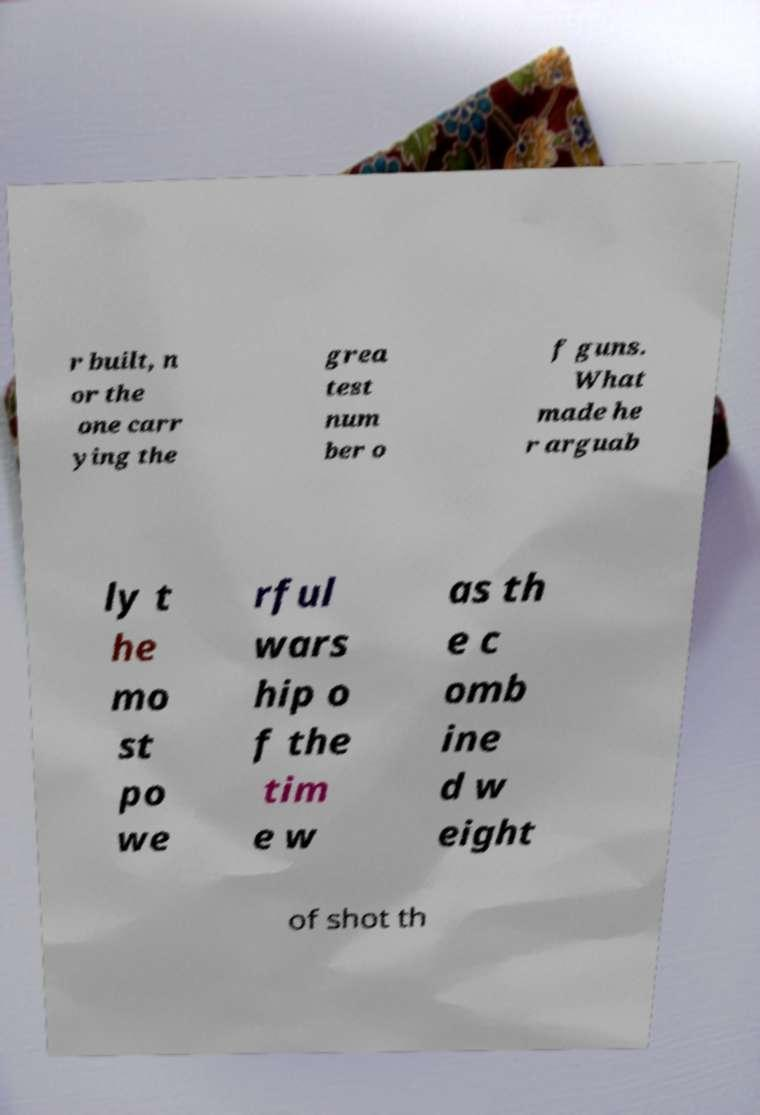Please identify and transcribe the text found in this image. r built, n or the one carr ying the grea test num ber o f guns. What made he r arguab ly t he mo st po we rful wars hip o f the tim e w as th e c omb ine d w eight of shot th 